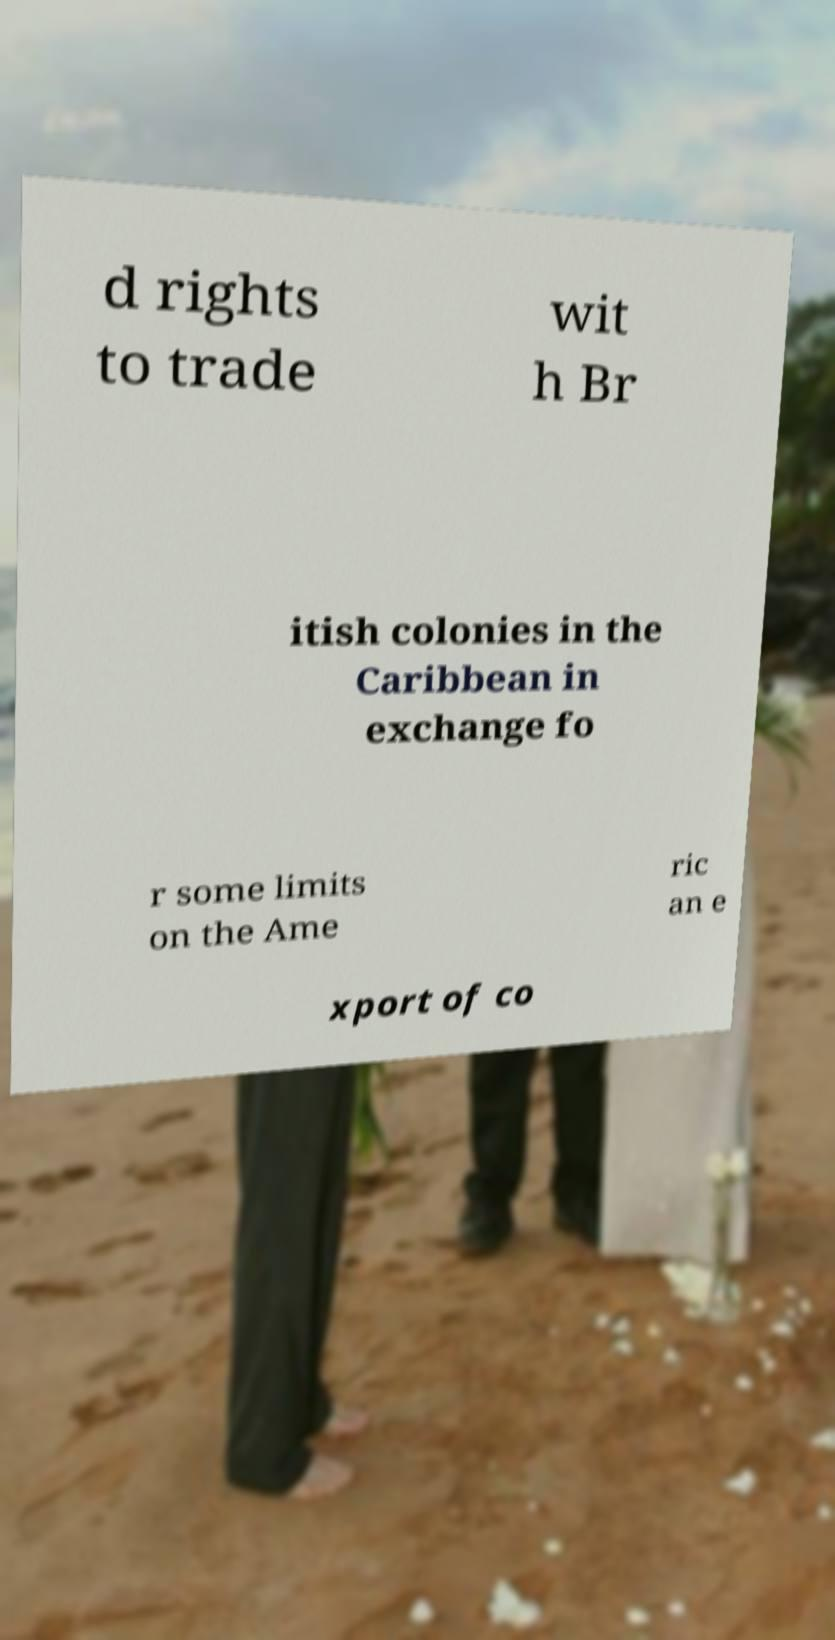Could you extract and type out the text from this image? d rights to trade wit h Br itish colonies in the Caribbean in exchange fo r some limits on the Ame ric an e xport of co 